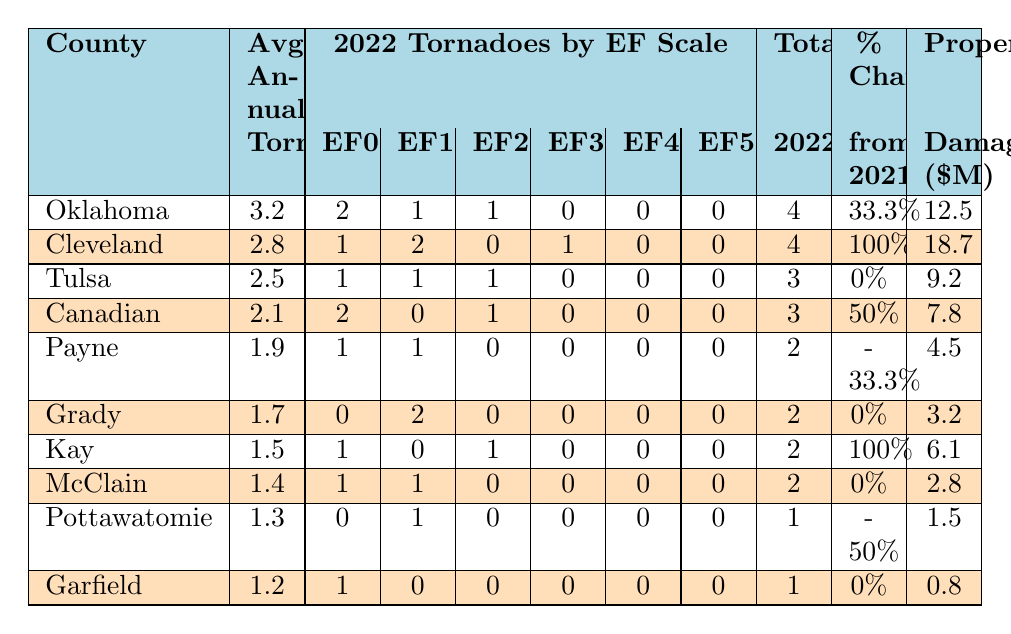What is the county with the highest average annual tornadoes? By looking at the "Avg Annual Tornadoes" column, we find that Oklahoma county has the highest value at 3.2.
Answer: Oklahoma How many total tornadoes were recorded in Cleveland county in 2022? The total tornadoes for Cleveland county in 2022 is listed directly in the table under "Total 2022," which shows a value of 4.
Answer: 4 Which county experienced a percent change of -50% compared to 2021? Checking the "% Change from 2021" column, Pottawatomie county shows a value of -50%.
Answer: Pottawatomie What was the total property damage in millions for Kay county? The value of property damage for Kay county is noted in the "Property Damage ($M)" column, which indicates 6.1 million.
Answer: 6.1 Is there any county that reported zero EF3, EF4, and EF5 tornadoes in 2022? By examining the EF scale columns (EF3, EF4, EF5), all counties report zero for EF3, EF4, and EF5 tornadoes, indicating no counties had any of these.
Answer: Yes What is the total number of tornadoes for all counties reported in 2022? To find the total, sum up each county's total tornadoes: 4 + 4 + 3 + 3 + 2 + 2 + 2 + 2 + 1 + 1 = 24.
Answer: 24 How much property damage was recorded in the county with the lowest average annual tornadoes? The county with the lowest average (Garfield) has property damage of 0.8 million dollars, directly taken from the "Property Damage ($M)" column.
Answer: 0.8 Which county had the highest property damage in 2022? Looking at the "Property Damage ($M)" column, Cleveland county shows the highest value at 18.7 million.
Answer: Cleveland How many EF1 tornadoes were reported across all counties combined in 2022? To find this, sum the EF1 tornadoes across all counties: 1 + 2 + 1 + 0 + 1 + 2 + 0 + 1 + 1 + 0 = 9.
Answer: 9 What is the difference in average annual tornadoes between Oklahoma and Pottawatomie county? The average annual tornadoes for Oklahoma is 3.2, while for Pottawatomie it is 1.3. The difference is 3.2 - 1.3 = 1.9.
Answer: 1.9 Which county had a 100% increase in tornadoes from 2021 to 2022? Checking the "% Change from 2021" column, both Cleveland and Kay counties had a 100% increase.
Answer: Cleveland and Kay 